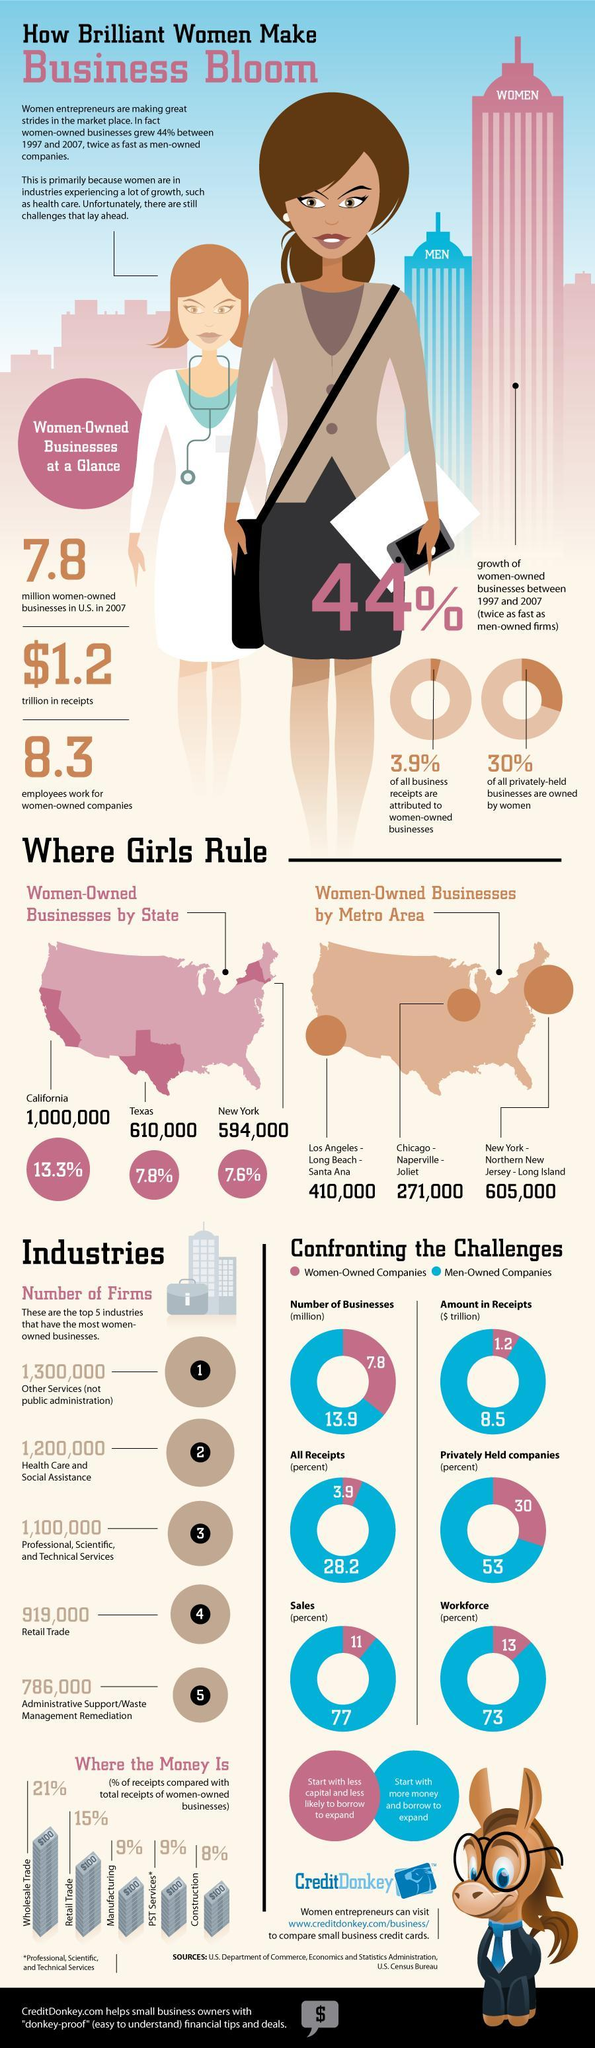How many privately held companies are men-owned?
Answer the question with a short phrase. 53% How many privately held companies are women-owned? 30% Which state has the third highest number of women-owned businesses? New York How many more men-owned companies are there than women-owned companies? 6.1 million Which is the top second industry among the top 5 that has the most women-owned businesses? Health care and Social Assistance How much do the men-owned companies contribute to workforce? 73% Which metro area has the most number of women-owned businesses? New York-Northern New Jersey-Long Island Which state has the second highest number of women-owned businesses? Texas How much do the women-owned companies contribute to workforce? 13% Which is the top fourth industry among the top 5 that has the most women-owned businesses? Retail Trade Which state has the most number of women-owned businesses? California Which is the top third industry among the top 5 that has the most women-owned businesses? Professional,Scientific,and Technical services 